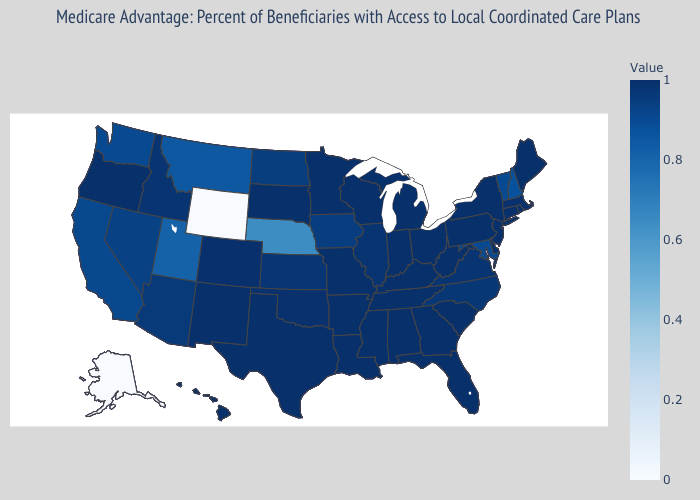Which states have the lowest value in the USA?
Concise answer only. Alaska, Wyoming. Does Iowa have the lowest value in the MidWest?
Write a very short answer. No. Which states have the lowest value in the USA?
Write a very short answer. Alaska, Wyoming. 